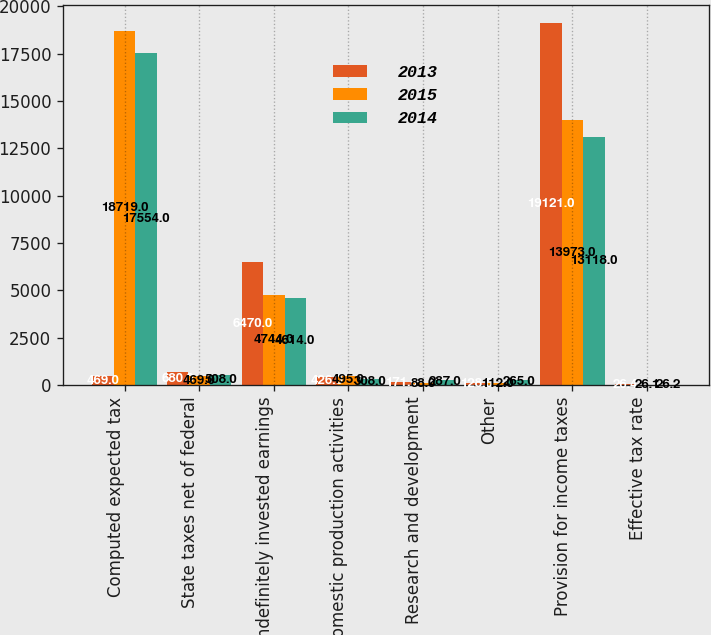Convert chart. <chart><loc_0><loc_0><loc_500><loc_500><stacked_bar_chart><ecel><fcel>Computed expected tax<fcel>State taxes net of federal<fcel>Indefinitely invested earnings<fcel>Domestic production activities<fcel>Research and development<fcel>Other<fcel>Provision for income taxes<fcel>Effective tax rate<nl><fcel>2013<fcel>469<fcel>680<fcel>6470<fcel>426<fcel>171<fcel>128<fcel>19121<fcel>26.4<nl><fcel>2015<fcel>18719<fcel>469<fcel>4744<fcel>495<fcel>88<fcel>112<fcel>13973<fcel>26.1<nl><fcel>2014<fcel>17554<fcel>508<fcel>4614<fcel>308<fcel>287<fcel>265<fcel>13118<fcel>26.2<nl></chart> 